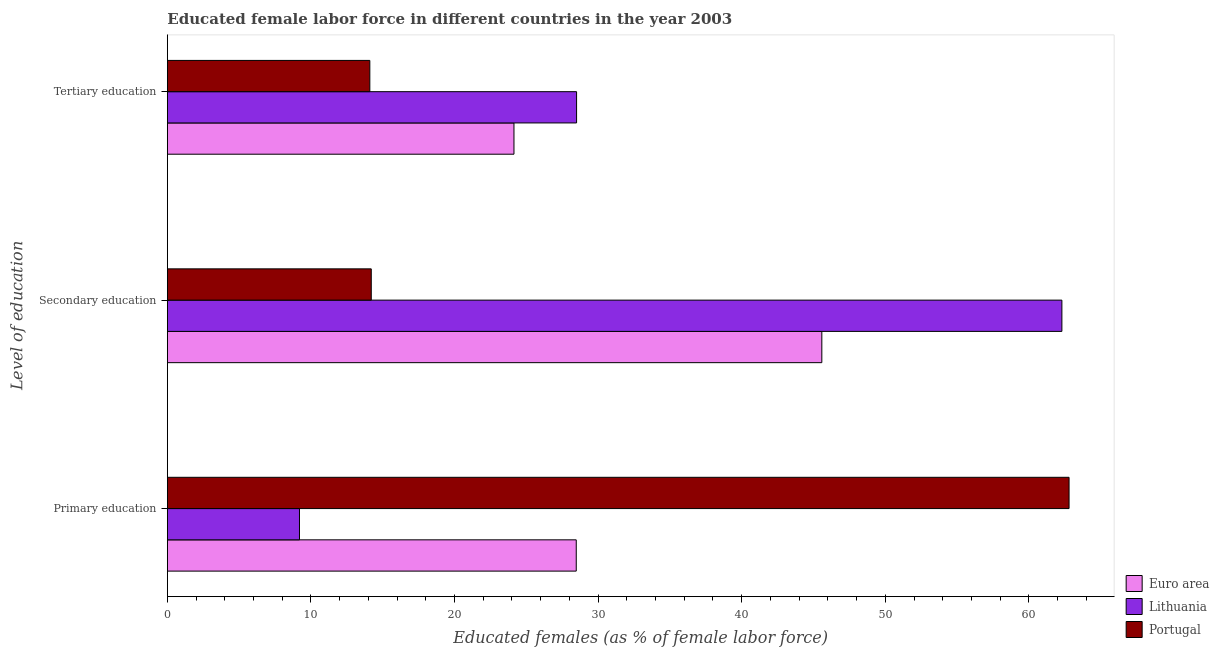Are the number of bars per tick equal to the number of legend labels?
Provide a succinct answer. Yes. Are the number of bars on each tick of the Y-axis equal?
Provide a succinct answer. Yes. How many bars are there on the 2nd tick from the top?
Offer a very short reply. 3. What is the percentage of female labor force who received secondary education in Lithuania?
Ensure brevity in your answer.  62.3. Across all countries, what is the maximum percentage of female labor force who received primary education?
Offer a very short reply. 62.8. Across all countries, what is the minimum percentage of female labor force who received primary education?
Make the answer very short. 9.2. In which country was the percentage of female labor force who received secondary education maximum?
Offer a very short reply. Lithuania. What is the total percentage of female labor force who received tertiary education in the graph?
Your answer should be compact. 66.74. What is the difference between the percentage of female labor force who received secondary education in Portugal and that in Lithuania?
Offer a terse response. -48.1. What is the difference between the percentage of female labor force who received tertiary education in Lithuania and the percentage of female labor force who received primary education in Portugal?
Ensure brevity in your answer.  -34.3. What is the average percentage of female labor force who received primary education per country?
Ensure brevity in your answer.  33.49. What is the difference between the percentage of female labor force who received tertiary education and percentage of female labor force who received primary education in Lithuania?
Provide a succinct answer. 19.3. What is the ratio of the percentage of female labor force who received primary education in Portugal to that in Euro area?
Ensure brevity in your answer.  2.21. Is the percentage of female labor force who received tertiary education in Lithuania less than that in Euro area?
Provide a short and direct response. No. Is the difference between the percentage of female labor force who received tertiary education in Lithuania and Euro area greater than the difference between the percentage of female labor force who received secondary education in Lithuania and Euro area?
Offer a very short reply. No. What is the difference between the highest and the second highest percentage of female labor force who received primary education?
Offer a very short reply. 34.32. What is the difference between the highest and the lowest percentage of female labor force who received tertiary education?
Offer a very short reply. 14.4. In how many countries, is the percentage of female labor force who received secondary education greater than the average percentage of female labor force who received secondary education taken over all countries?
Your answer should be compact. 2. What does the 2nd bar from the top in Tertiary education represents?
Keep it short and to the point. Lithuania. What does the 3rd bar from the bottom in Secondary education represents?
Provide a succinct answer. Portugal. How many bars are there?
Provide a short and direct response. 9. What is the difference between two consecutive major ticks on the X-axis?
Your answer should be compact. 10. Does the graph contain any zero values?
Your response must be concise. No. Where does the legend appear in the graph?
Offer a terse response. Bottom right. How are the legend labels stacked?
Provide a short and direct response. Vertical. What is the title of the graph?
Ensure brevity in your answer.  Educated female labor force in different countries in the year 2003. What is the label or title of the X-axis?
Provide a short and direct response. Educated females (as % of female labor force). What is the label or title of the Y-axis?
Make the answer very short. Level of education. What is the Educated females (as % of female labor force) of Euro area in Primary education?
Provide a short and direct response. 28.48. What is the Educated females (as % of female labor force) of Lithuania in Primary education?
Offer a very short reply. 9.2. What is the Educated females (as % of female labor force) in Portugal in Primary education?
Provide a short and direct response. 62.8. What is the Educated females (as % of female labor force) in Euro area in Secondary education?
Keep it short and to the point. 45.58. What is the Educated females (as % of female labor force) in Lithuania in Secondary education?
Your answer should be very brief. 62.3. What is the Educated females (as % of female labor force) of Portugal in Secondary education?
Keep it short and to the point. 14.2. What is the Educated females (as % of female labor force) in Euro area in Tertiary education?
Keep it short and to the point. 24.14. What is the Educated females (as % of female labor force) of Portugal in Tertiary education?
Your answer should be compact. 14.1. Across all Level of education, what is the maximum Educated females (as % of female labor force) in Euro area?
Give a very brief answer. 45.58. Across all Level of education, what is the maximum Educated females (as % of female labor force) of Lithuania?
Ensure brevity in your answer.  62.3. Across all Level of education, what is the maximum Educated females (as % of female labor force) in Portugal?
Provide a short and direct response. 62.8. Across all Level of education, what is the minimum Educated females (as % of female labor force) in Euro area?
Your response must be concise. 24.14. Across all Level of education, what is the minimum Educated females (as % of female labor force) of Lithuania?
Offer a very short reply. 9.2. Across all Level of education, what is the minimum Educated females (as % of female labor force) of Portugal?
Provide a short and direct response. 14.1. What is the total Educated females (as % of female labor force) in Euro area in the graph?
Keep it short and to the point. 98.2. What is the total Educated females (as % of female labor force) in Portugal in the graph?
Keep it short and to the point. 91.1. What is the difference between the Educated females (as % of female labor force) of Euro area in Primary education and that in Secondary education?
Keep it short and to the point. -17.1. What is the difference between the Educated females (as % of female labor force) of Lithuania in Primary education and that in Secondary education?
Offer a very short reply. -53.1. What is the difference between the Educated females (as % of female labor force) of Portugal in Primary education and that in Secondary education?
Your response must be concise. 48.6. What is the difference between the Educated females (as % of female labor force) in Euro area in Primary education and that in Tertiary education?
Your response must be concise. 4.34. What is the difference between the Educated females (as % of female labor force) of Lithuania in Primary education and that in Tertiary education?
Your answer should be compact. -19.3. What is the difference between the Educated females (as % of female labor force) of Portugal in Primary education and that in Tertiary education?
Your response must be concise. 48.7. What is the difference between the Educated females (as % of female labor force) of Euro area in Secondary education and that in Tertiary education?
Your answer should be compact. 21.44. What is the difference between the Educated females (as % of female labor force) in Lithuania in Secondary education and that in Tertiary education?
Your answer should be compact. 33.8. What is the difference between the Educated females (as % of female labor force) of Portugal in Secondary education and that in Tertiary education?
Your answer should be very brief. 0.1. What is the difference between the Educated females (as % of female labor force) of Euro area in Primary education and the Educated females (as % of female labor force) of Lithuania in Secondary education?
Offer a very short reply. -33.82. What is the difference between the Educated females (as % of female labor force) of Euro area in Primary education and the Educated females (as % of female labor force) of Portugal in Secondary education?
Give a very brief answer. 14.28. What is the difference between the Educated females (as % of female labor force) in Lithuania in Primary education and the Educated females (as % of female labor force) in Portugal in Secondary education?
Make the answer very short. -5. What is the difference between the Educated females (as % of female labor force) in Euro area in Primary education and the Educated females (as % of female labor force) in Lithuania in Tertiary education?
Your response must be concise. -0.02. What is the difference between the Educated females (as % of female labor force) in Euro area in Primary education and the Educated females (as % of female labor force) in Portugal in Tertiary education?
Ensure brevity in your answer.  14.38. What is the difference between the Educated females (as % of female labor force) in Euro area in Secondary education and the Educated females (as % of female labor force) in Lithuania in Tertiary education?
Keep it short and to the point. 17.08. What is the difference between the Educated females (as % of female labor force) in Euro area in Secondary education and the Educated females (as % of female labor force) in Portugal in Tertiary education?
Your answer should be compact. 31.48. What is the difference between the Educated females (as % of female labor force) in Lithuania in Secondary education and the Educated females (as % of female labor force) in Portugal in Tertiary education?
Give a very brief answer. 48.2. What is the average Educated females (as % of female labor force) in Euro area per Level of education?
Make the answer very short. 32.73. What is the average Educated females (as % of female labor force) of Lithuania per Level of education?
Offer a very short reply. 33.33. What is the average Educated females (as % of female labor force) in Portugal per Level of education?
Your response must be concise. 30.37. What is the difference between the Educated females (as % of female labor force) in Euro area and Educated females (as % of female labor force) in Lithuania in Primary education?
Your answer should be very brief. 19.28. What is the difference between the Educated females (as % of female labor force) in Euro area and Educated females (as % of female labor force) in Portugal in Primary education?
Offer a very short reply. -34.32. What is the difference between the Educated females (as % of female labor force) in Lithuania and Educated females (as % of female labor force) in Portugal in Primary education?
Provide a short and direct response. -53.6. What is the difference between the Educated females (as % of female labor force) in Euro area and Educated females (as % of female labor force) in Lithuania in Secondary education?
Your answer should be very brief. -16.72. What is the difference between the Educated females (as % of female labor force) of Euro area and Educated females (as % of female labor force) of Portugal in Secondary education?
Provide a short and direct response. 31.38. What is the difference between the Educated females (as % of female labor force) of Lithuania and Educated females (as % of female labor force) of Portugal in Secondary education?
Your answer should be compact. 48.1. What is the difference between the Educated females (as % of female labor force) in Euro area and Educated females (as % of female labor force) in Lithuania in Tertiary education?
Your answer should be very brief. -4.36. What is the difference between the Educated females (as % of female labor force) of Euro area and Educated females (as % of female labor force) of Portugal in Tertiary education?
Your answer should be compact. 10.04. What is the difference between the Educated females (as % of female labor force) of Lithuania and Educated females (as % of female labor force) of Portugal in Tertiary education?
Provide a succinct answer. 14.4. What is the ratio of the Educated females (as % of female labor force) in Euro area in Primary education to that in Secondary education?
Your answer should be very brief. 0.62. What is the ratio of the Educated females (as % of female labor force) of Lithuania in Primary education to that in Secondary education?
Give a very brief answer. 0.15. What is the ratio of the Educated females (as % of female labor force) of Portugal in Primary education to that in Secondary education?
Your response must be concise. 4.42. What is the ratio of the Educated females (as % of female labor force) of Euro area in Primary education to that in Tertiary education?
Your response must be concise. 1.18. What is the ratio of the Educated females (as % of female labor force) of Lithuania in Primary education to that in Tertiary education?
Provide a succinct answer. 0.32. What is the ratio of the Educated females (as % of female labor force) of Portugal in Primary education to that in Tertiary education?
Your answer should be compact. 4.45. What is the ratio of the Educated females (as % of female labor force) in Euro area in Secondary education to that in Tertiary education?
Make the answer very short. 1.89. What is the ratio of the Educated females (as % of female labor force) of Lithuania in Secondary education to that in Tertiary education?
Make the answer very short. 2.19. What is the ratio of the Educated females (as % of female labor force) of Portugal in Secondary education to that in Tertiary education?
Provide a short and direct response. 1.01. What is the difference between the highest and the second highest Educated females (as % of female labor force) in Euro area?
Provide a succinct answer. 17.1. What is the difference between the highest and the second highest Educated females (as % of female labor force) in Lithuania?
Give a very brief answer. 33.8. What is the difference between the highest and the second highest Educated females (as % of female labor force) in Portugal?
Offer a very short reply. 48.6. What is the difference between the highest and the lowest Educated females (as % of female labor force) in Euro area?
Offer a terse response. 21.44. What is the difference between the highest and the lowest Educated females (as % of female labor force) in Lithuania?
Provide a short and direct response. 53.1. What is the difference between the highest and the lowest Educated females (as % of female labor force) of Portugal?
Offer a terse response. 48.7. 